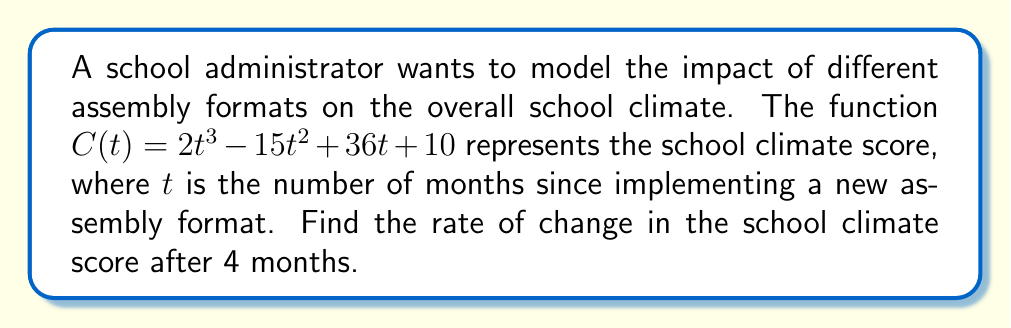Teach me how to tackle this problem. To find the rate of change in the school climate score after 4 months, we need to calculate the derivative of the function $C(t)$ and evaluate it at $t=4$. Let's follow these steps:

1) The given function is $C(t) = 2t^3 - 15t^2 + 36t + 10$

2) To find the derivative $C'(t)$, we apply the power rule and constant rule:
   $C'(t) = 6t^2 - 30t + 36$

3) Now, we need to evaluate $C'(4)$:
   $C'(4) = 6(4)^2 - 30(4) + 36$

4) Let's calculate step by step:
   $C'(4) = 6(16) - 120 + 36$
   $C'(4) = 96 - 120 + 36$
   $C'(4) = 12$

5) Therefore, the rate of change in the school climate score after 4 months is 12 units per month.
Answer: 12 units per month 